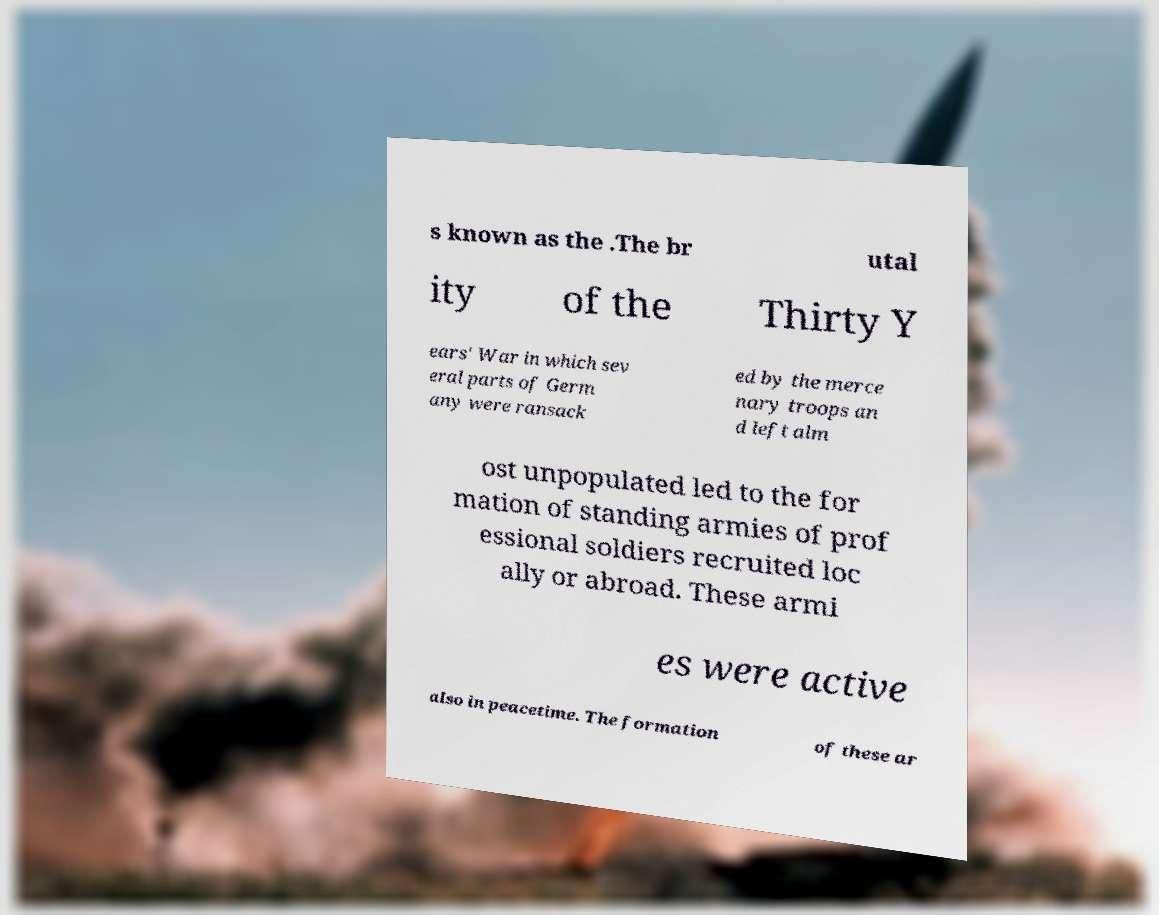Could you assist in decoding the text presented in this image and type it out clearly? s known as the .The br utal ity of the Thirty Y ears' War in which sev eral parts of Germ any were ransack ed by the merce nary troops an d left alm ost unpopulated led to the for mation of standing armies of prof essional soldiers recruited loc ally or abroad. These armi es were active also in peacetime. The formation of these ar 